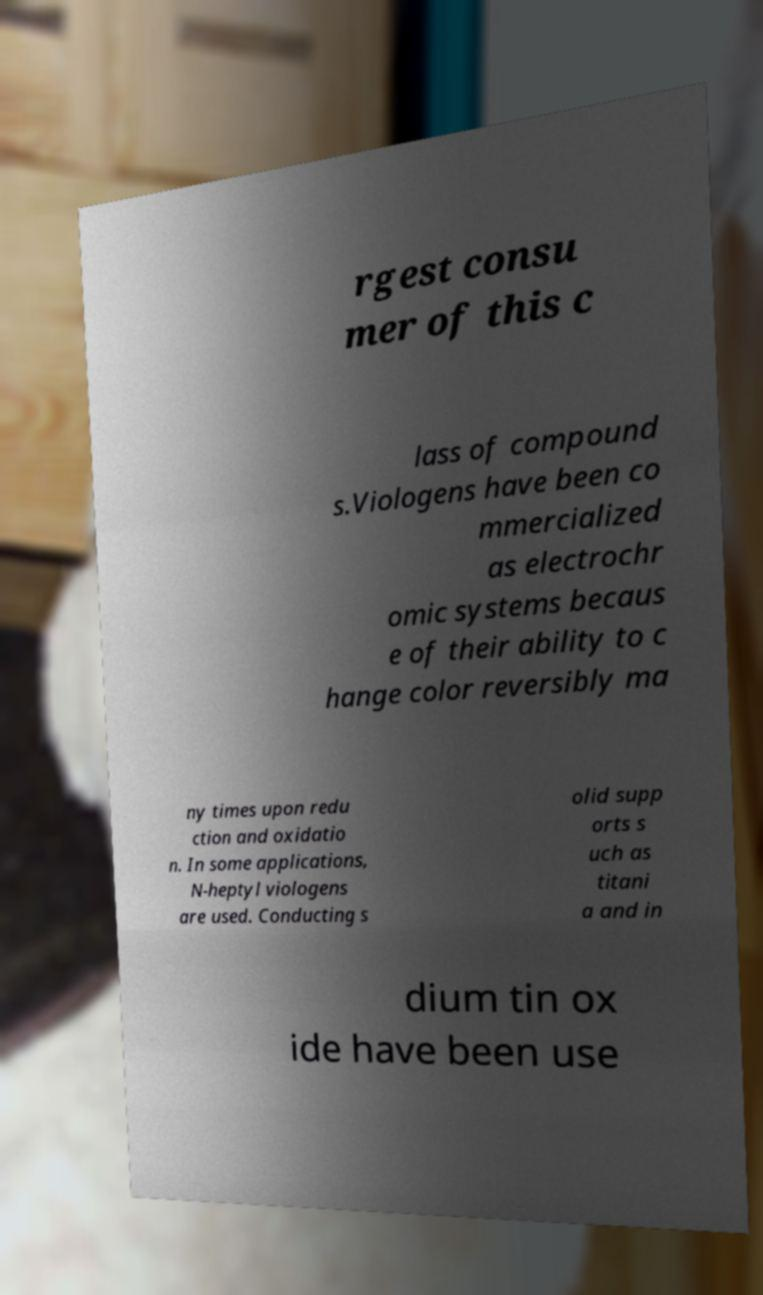What messages or text are displayed in this image? I need them in a readable, typed format. rgest consu mer of this c lass of compound s.Viologens have been co mmercialized as electrochr omic systems becaus e of their ability to c hange color reversibly ma ny times upon redu ction and oxidatio n. In some applications, N-heptyl viologens are used. Conducting s olid supp orts s uch as titani a and in dium tin ox ide have been use 